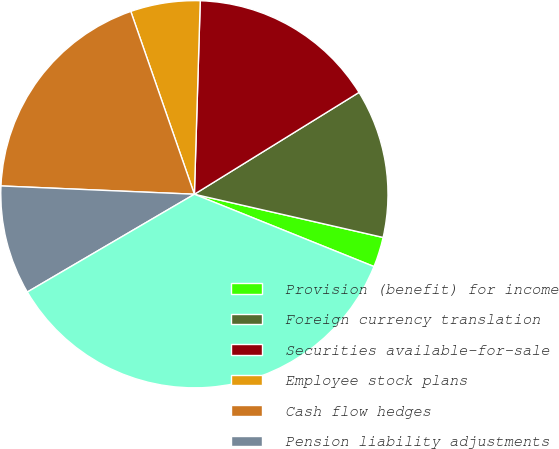Convert chart to OTSL. <chart><loc_0><loc_0><loc_500><loc_500><pie_chart><fcel>Provision (benefit) for income<fcel>Foreign currency translation<fcel>Securities available-for-sale<fcel>Employee stock plans<fcel>Cash flow hedges<fcel>Pension liability adjustments<fcel>Income taxes before minority<nl><fcel>2.51%<fcel>12.4%<fcel>15.7%<fcel>5.81%<fcel>18.99%<fcel>9.11%<fcel>35.48%<nl></chart> 